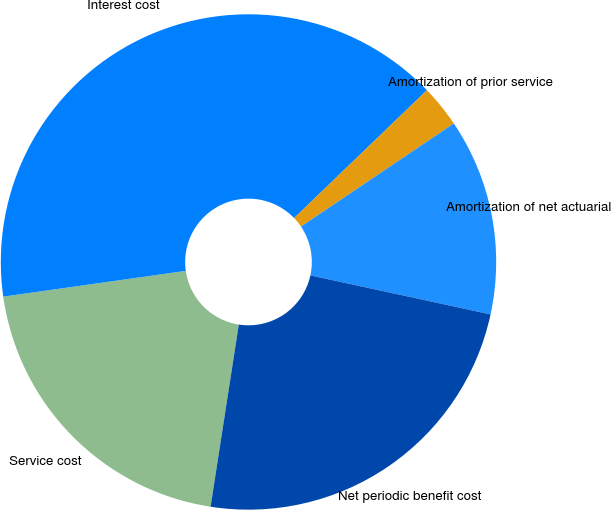Convert chart. <chart><loc_0><loc_0><loc_500><loc_500><pie_chart><fcel>Service cost<fcel>Interest cost<fcel>Amortization of prior service<fcel>Amortization of net actuarial<fcel>Net periodic benefit cost<nl><fcel>20.32%<fcel>40.04%<fcel>2.75%<fcel>12.84%<fcel>24.05%<nl></chart> 